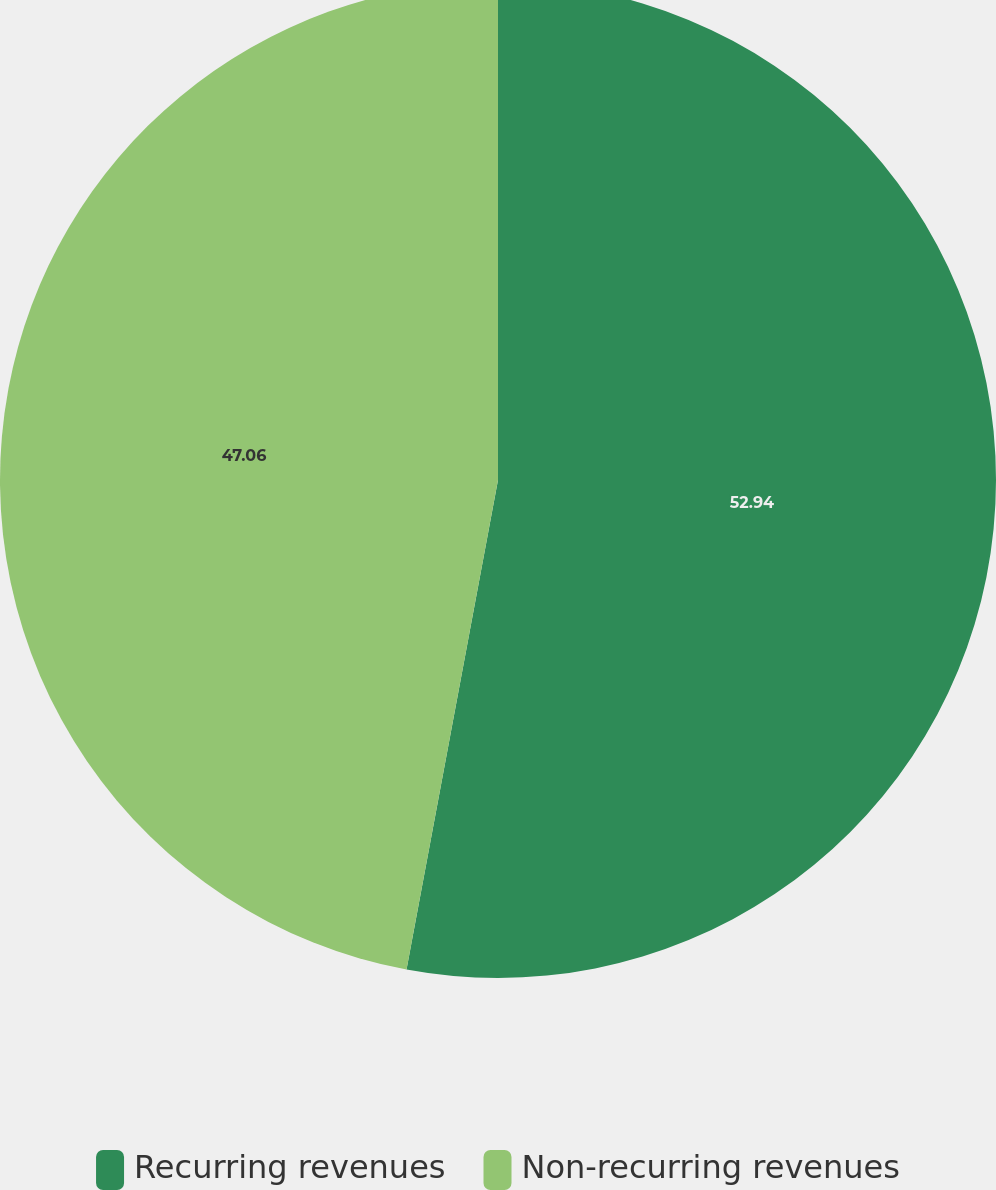<chart> <loc_0><loc_0><loc_500><loc_500><pie_chart><fcel>Recurring revenues<fcel>Non-recurring revenues<nl><fcel>52.94%<fcel>47.06%<nl></chart> 